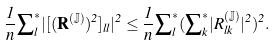<formula> <loc_0><loc_0><loc_500><loc_500>\frac { 1 } { n } { \sum } ^ { * } _ { l } | [ ( \mathbf R ^ { ( \mathbb { J } ) } ) ^ { 2 } ] _ { l l } | ^ { 2 } \leq \frac { 1 } { n } { \sum } ^ { * } _ { l } ( { \sum } ^ { * } _ { k } | R ^ { ( \mathbb { J } ) } _ { l k } | ^ { 2 } ) ^ { 2 } .</formula> 